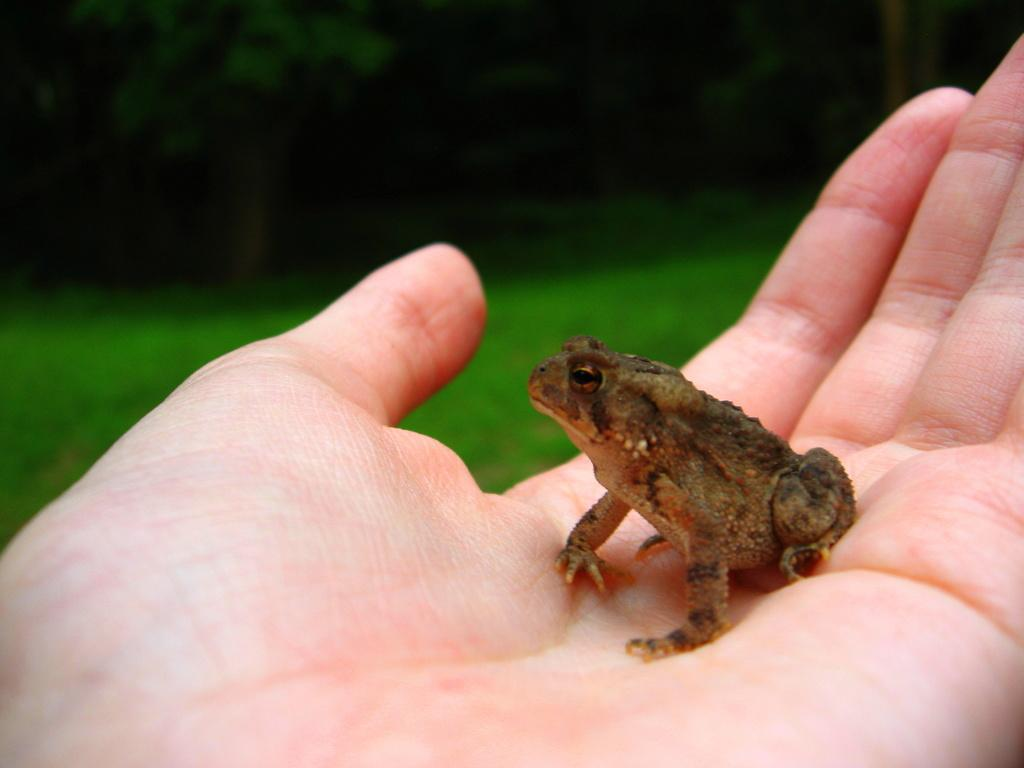What is visible in the image? There is a person's hand in the image. What is the hand holding? The hand is holding a frog. What type of pies can be seen in the image? There are no pies present in the image. What is inside the box in the image? There is no box present in the image. What type of light bulb is visible in the image? There is no light bulb present in the image. 